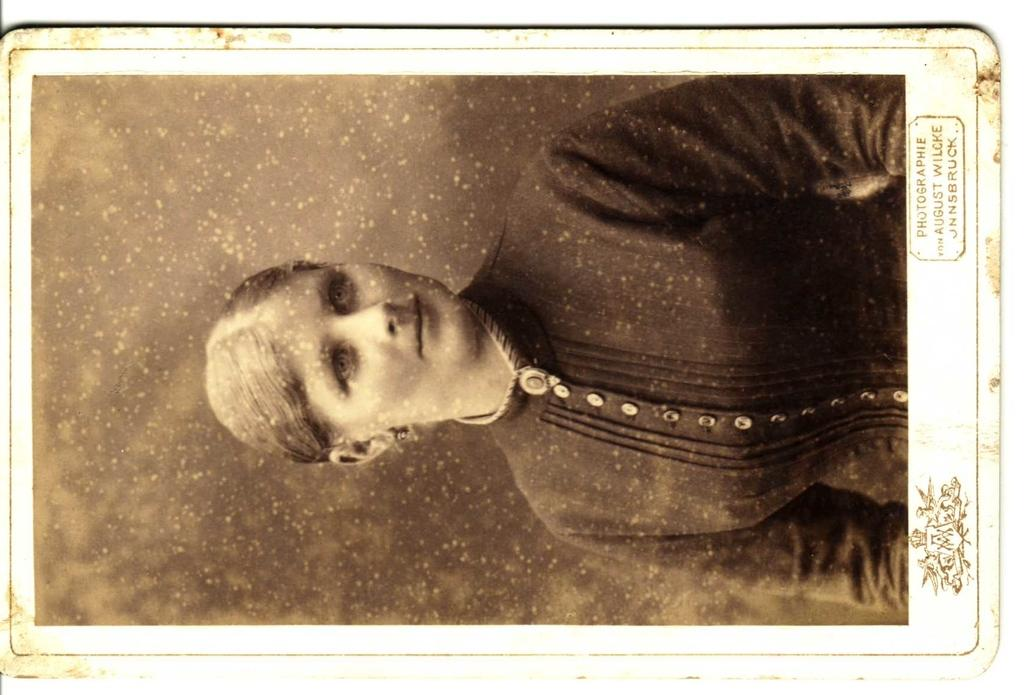What type of picture is in the image? The image contains a black and white picture of a woman. What is the woman wearing in the picture? The woman is wearing a dress in the picture. What additional information is present at the bottom of the image? There is text and a logo at the bottom of the image. How many tigers can be seen in the image? There are no tigers present in the image; it features a black and white picture of a woman. What type of park is visible in the image? There is no park visible in the image; it contains a picture of a woman and text with a logo at the bottom. 